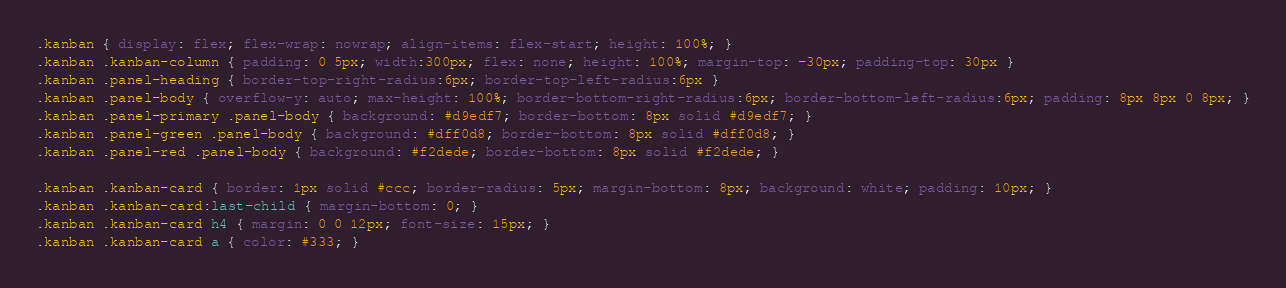Convert code to text. <code><loc_0><loc_0><loc_500><loc_500><_CSS_>.kanban { display: flex; flex-wrap: nowrap; align-items: flex-start; height: 100%; }
.kanban .kanban-column { padding: 0 5px; width:300px; flex: none; height: 100%; margin-top: -30px; padding-top: 30px }
.kanban .panel-heading { border-top-right-radius:6px; border-top-left-radius:6px }
.kanban .panel-body { overflow-y: auto; max-height: 100%; border-bottom-right-radius:6px; border-bottom-left-radius:6px; padding: 8px 8px 0 8px; }
.kanban .panel-primary .panel-body { background: #d9edf7; border-bottom: 8px solid #d9edf7; }
.kanban .panel-green .panel-body { background: #dff0d8; border-bottom: 8px solid #dff0d8; }
.kanban .panel-red .panel-body { background: #f2dede; border-bottom: 8px solid #f2dede; }

.kanban .kanban-card { border: 1px solid #ccc; border-radius: 5px; margin-bottom: 8px; background: white; padding: 10px; }
.kanban .kanban-card:last-child { margin-bottom: 0; }
.kanban .kanban-card h4 { margin: 0 0 12px; font-size: 15px; }
.kanban .kanban-card a { color: #333; }</code> 